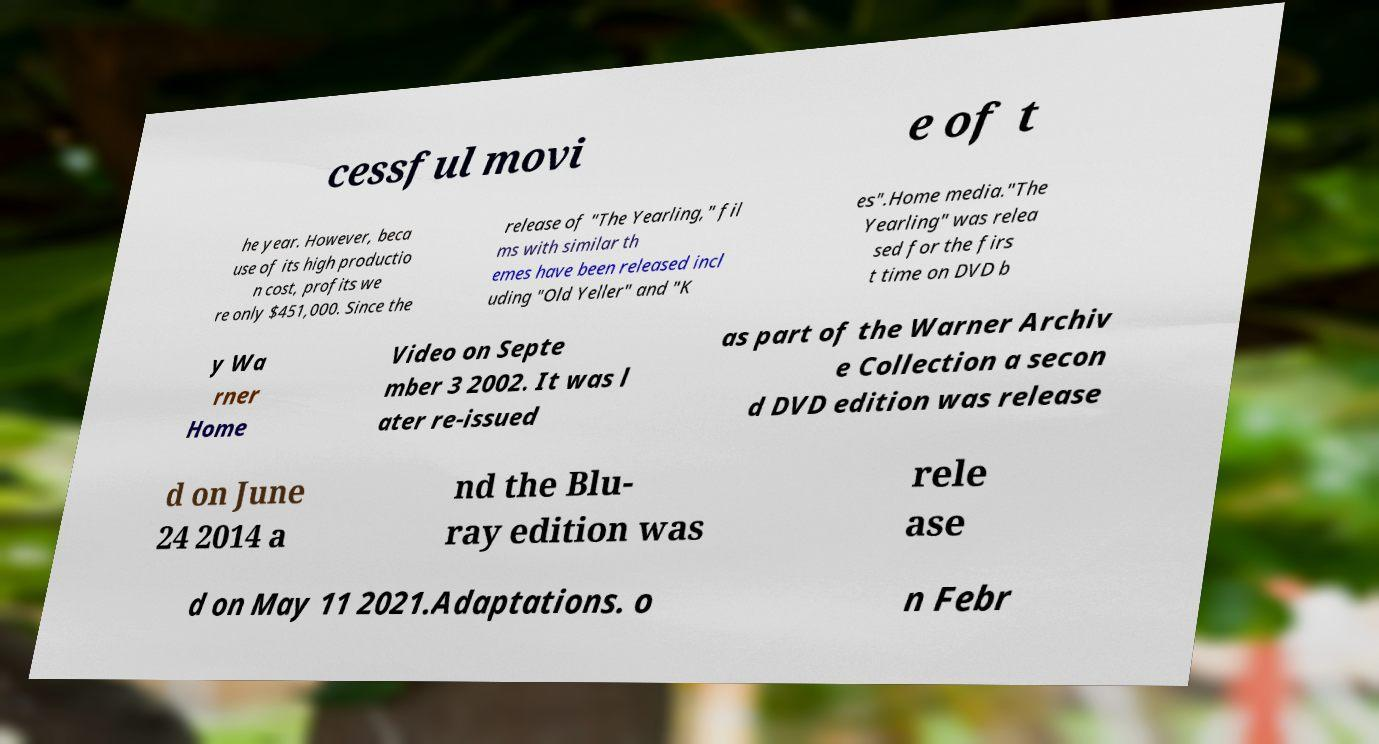Please read and relay the text visible in this image. What does it say? cessful movi e of t he year. However, beca use of its high productio n cost, profits we re only $451,000. Since the release of "The Yearling," fil ms with similar th emes have been released incl uding "Old Yeller" and "K es".Home media."The Yearling" was relea sed for the firs t time on DVD b y Wa rner Home Video on Septe mber 3 2002. It was l ater re-issued as part of the Warner Archiv e Collection a secon d DVD edition was release d on June 24 2014 a nd the Blu- ray edition was rele ase d on May 11 2021.Adaptations. o n Febr 